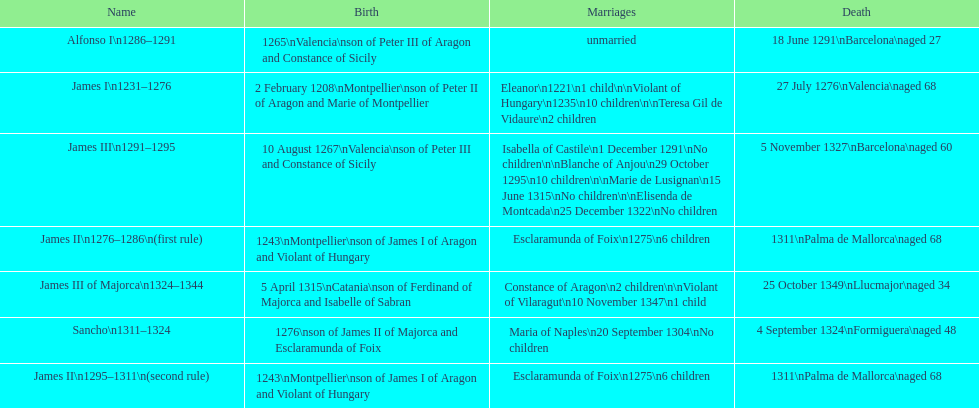Who came to power after the rule of james iii? James II. 